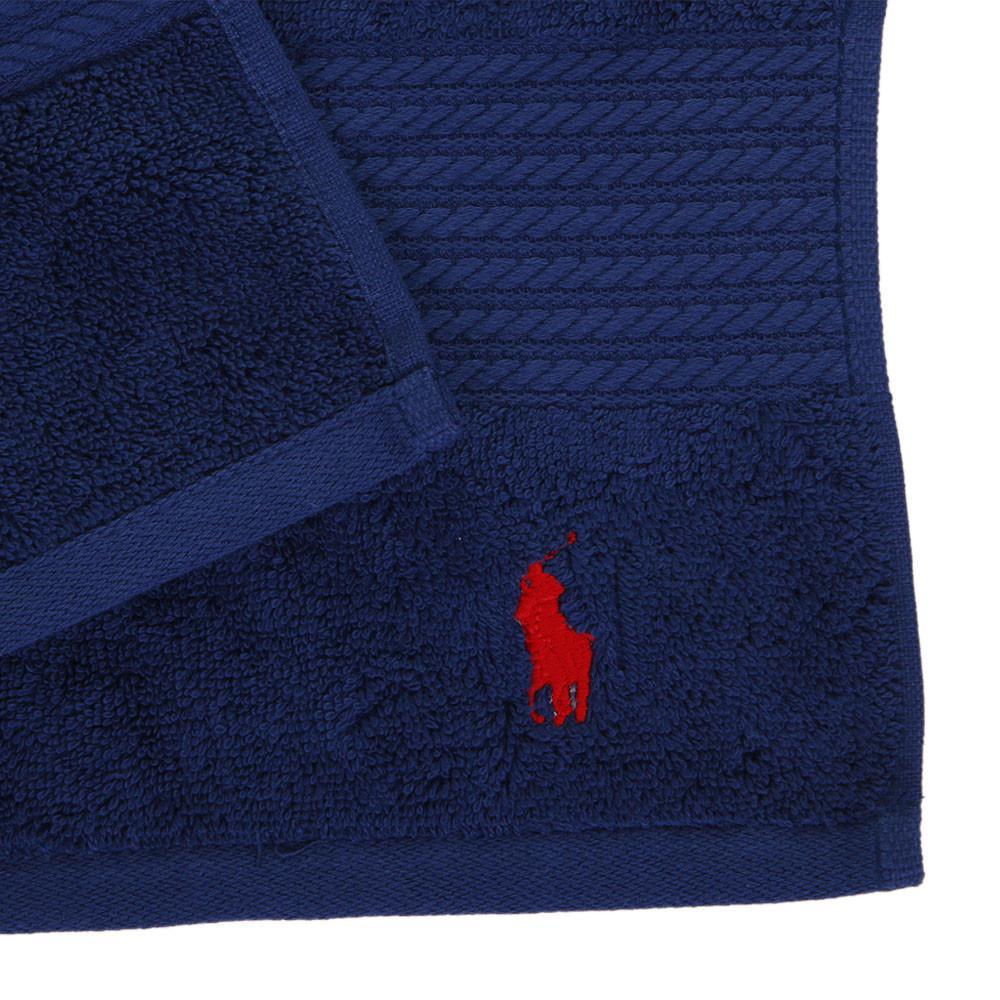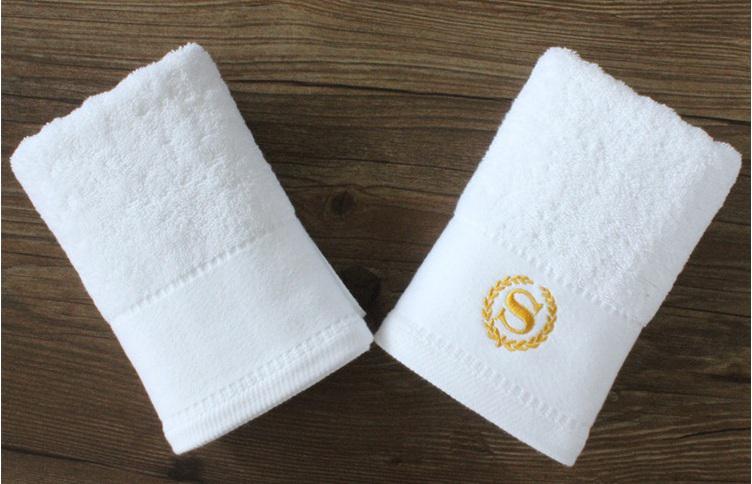The first image is the image on the left, the second image is the image on the right. Examine the images to the left and right. Is the description "In one of the images there is no towel with a logo of a different color than the towel." accurate? Answer yes or no. No. The first image is the image on the left, the second image is the image on the right. For the images shown, is this caption "The right image contains only white towels, while the left image has at least one blue towel." true? Answer yes or no. Yes. 